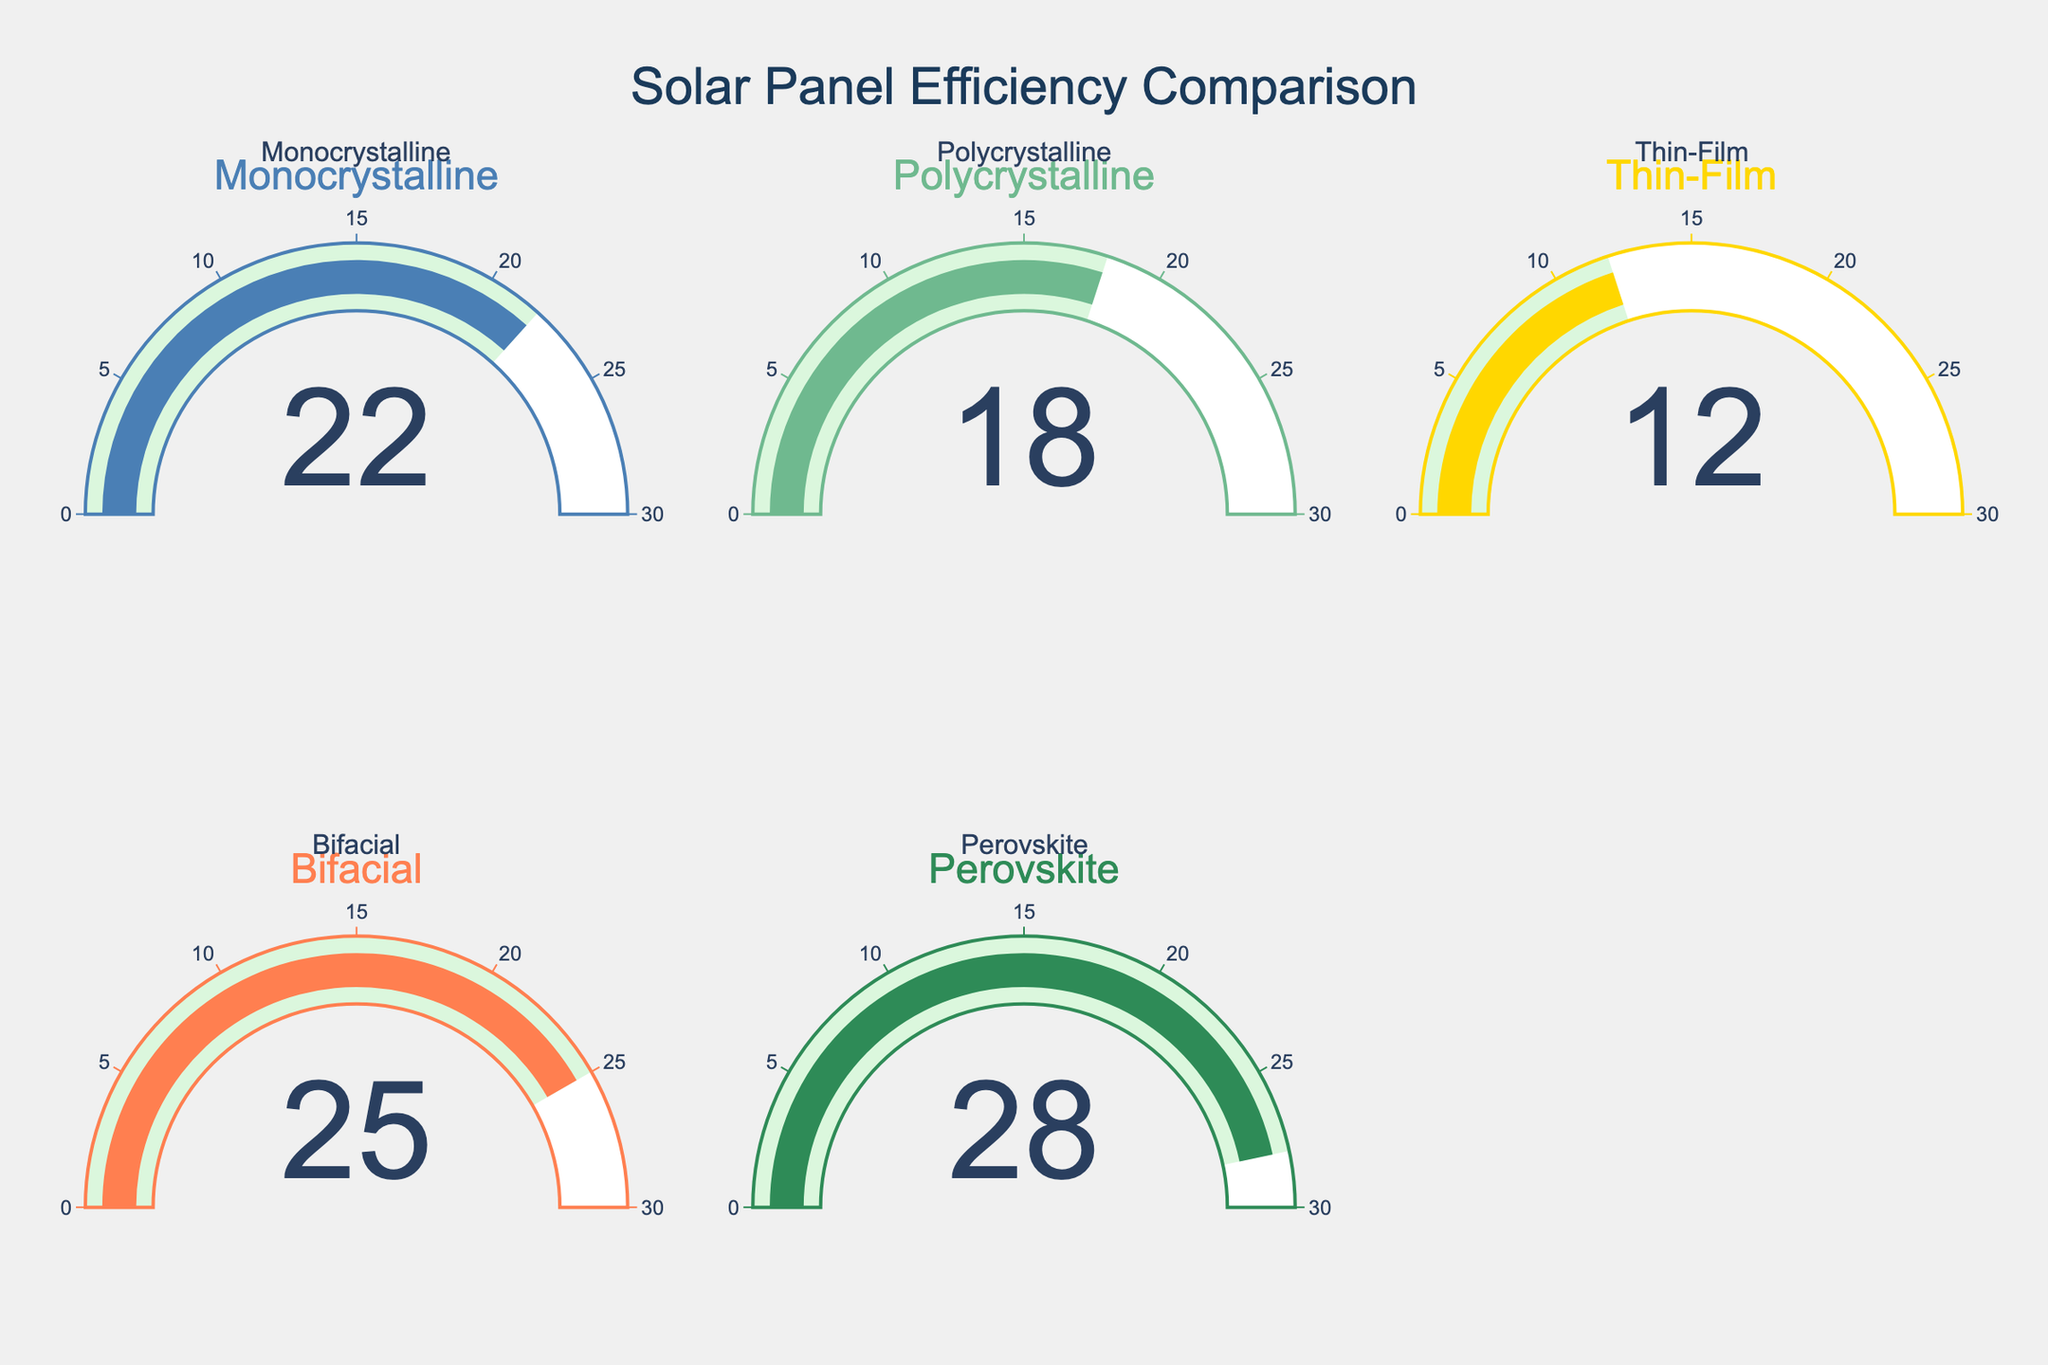Which solar panel type has the highest efficiency percentage? The gauge chart shows five types of solar panels with efficiency percentages. The highest value is indicated by the Perovskite type, which shows 28%.
Answer: Perovskite What is the range of efficiency percentages across all solar panel types? The lowest efficiency percentage is 12% (Thin-Film) and the highest is 28% (Perovskite). Therefore, the range is 28% - 12% = 16%.
Answer: 16% Compare the efficiency of Monocrystalline and Polycrystalline solar panels. Which one is higher, and by how much? Monocrystalline has an efficiency of 22%, and Polycrystalline has 18%. The difference is 22% - 18% = 4%.
Answer: Monocrystalline by 4% What is the average efficiency percentage of all the types of solar panels? Add all the efficiency percentages: 22% + 18% + 12% + 25% + 28% = 105%. The average is 105% / 5 = 21%.
Answer: 21% How much more efficient is Bifacial compared to Thin-Film solar panels? Bifacial has an efficiency of 25%, and Thin-Film has 12%. The difference is 25% - 12% = 13%.
Answer: 13% Which solar panel type has an efficiency closest to the average efficiency? The average efficiency percentage is 21%. The closest value to 21% is Monocrystalline with 22%.
Answer: Monocrystalline What is the total combined efficiency percentage of Monocrystalline and Perovskite solar panels? Monocrystalline's efficiency is 22%, and Perovskite's is 28%. The combined efficiency is 22% + 28% = 50%.
Answer: 50% What is the percentage difference between the panel types with the highest and lowest efficiency? The highest efficiency is 28% (Perovskite), and the lowest is 12% (Thin-Film). The percentage difference is (28% - 12%) / 12% * 100% = 133.33%.
Answer: 133.33% Out of the given solar panel types, which ones have an efficiency below 20%? The gauge chart shows Polycrystalline with 18% and Thin-Film with 12% as the types with efficiency below 20%.
Answer: Polycrystalline and Thin-Film 